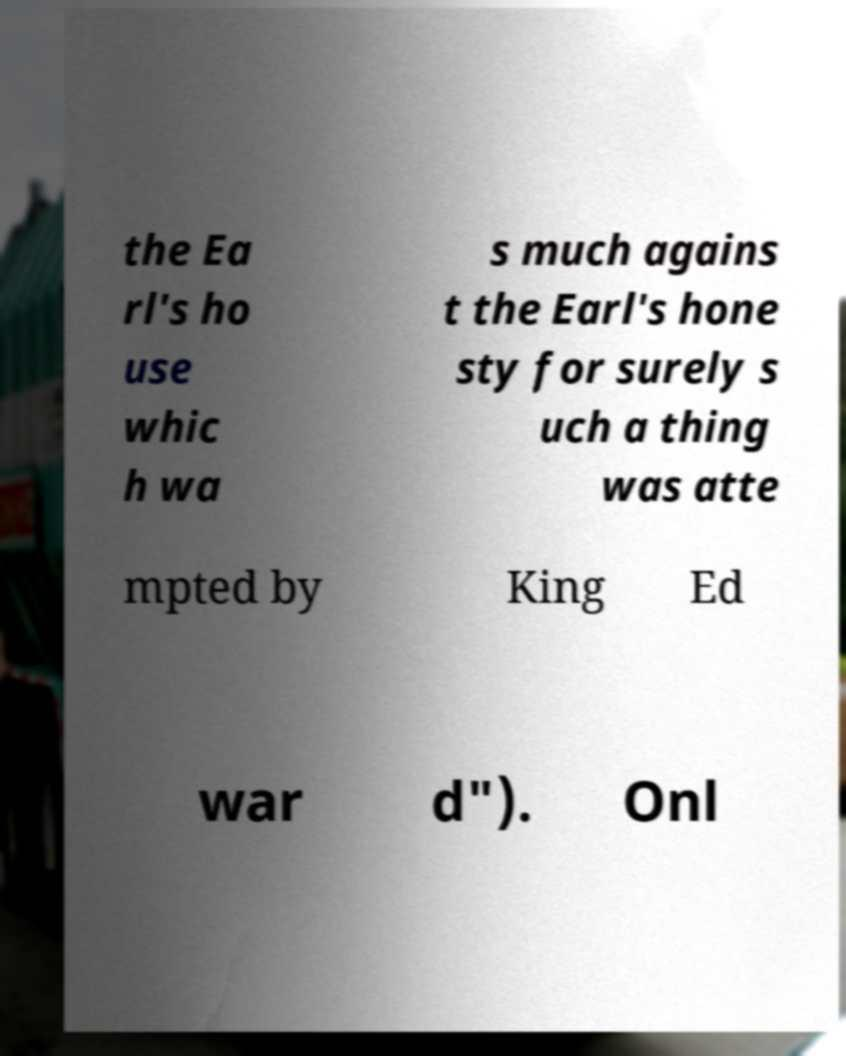Can you read and provide the text displayed in the image?This photo seems to have some interesting text. Can you extract and type it out for me? the Ea rl's ho use whic h wa s much agains t the Earl's hone sty for surely s uch a thing was atte mpted by King Ed war d"). Onl 